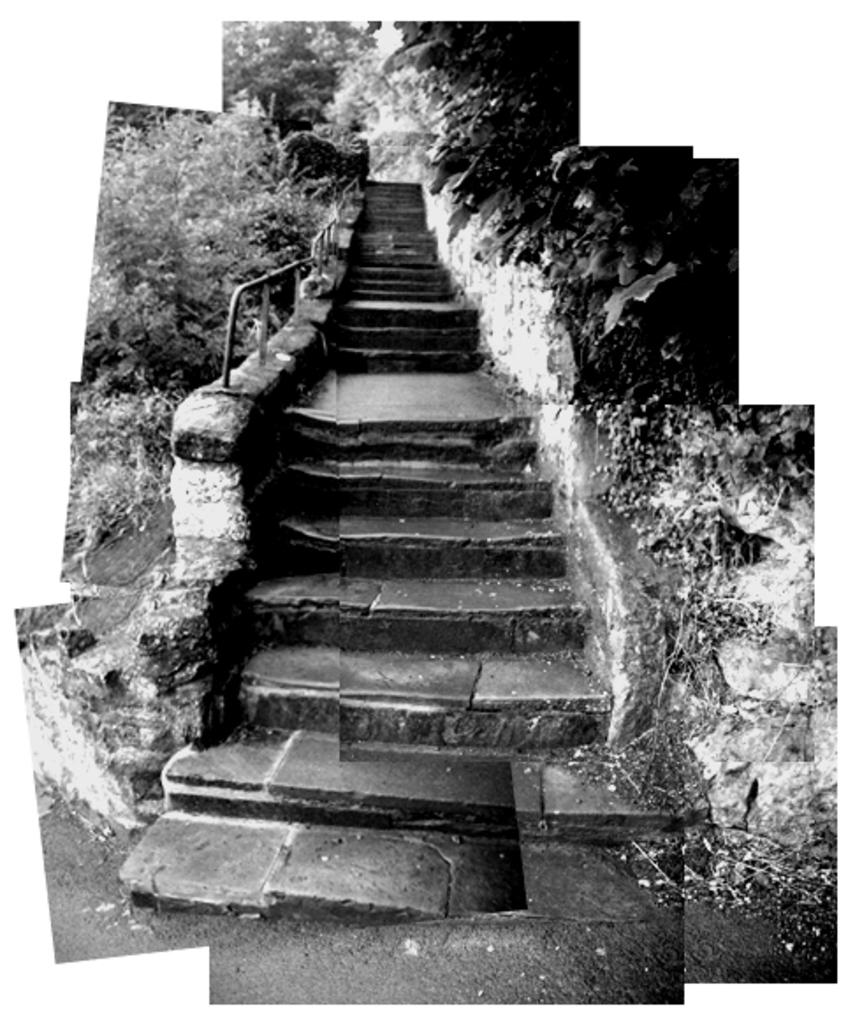What type of picture is in the image? The image contains a black and white picture. What architectural feature is present in the picture? There are stairs in the picture. What material is used for the railing on the stairs? The railing on the stairs is made of metal. What can be seen on both sides of the stairs in the picture? There are trees on both sides of the stairs. What type of temper does the harbor have in the image? There is no harbor present in the image, so it is not possible to determine its temper. 